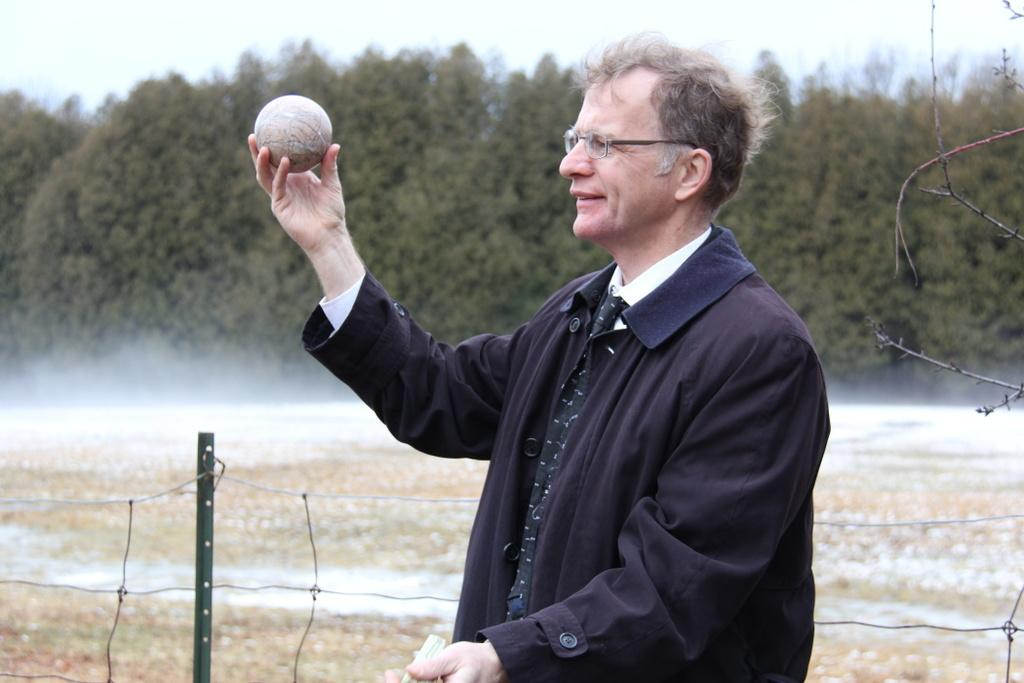Who is present in the image? There is a man in the image. What is the man holding in his hand? The man is holding a ball in his hand. Where is the man standing? The man is standing on the ground. What can be seen in the background of the image? Trees are present around the man. What type of letters can be seen in the image? There are no letters present in the image. How many people are in the crowd surrounding the man in the image? There is no crowd present in the image; it only features a man standing on the ground with trees in the background. 